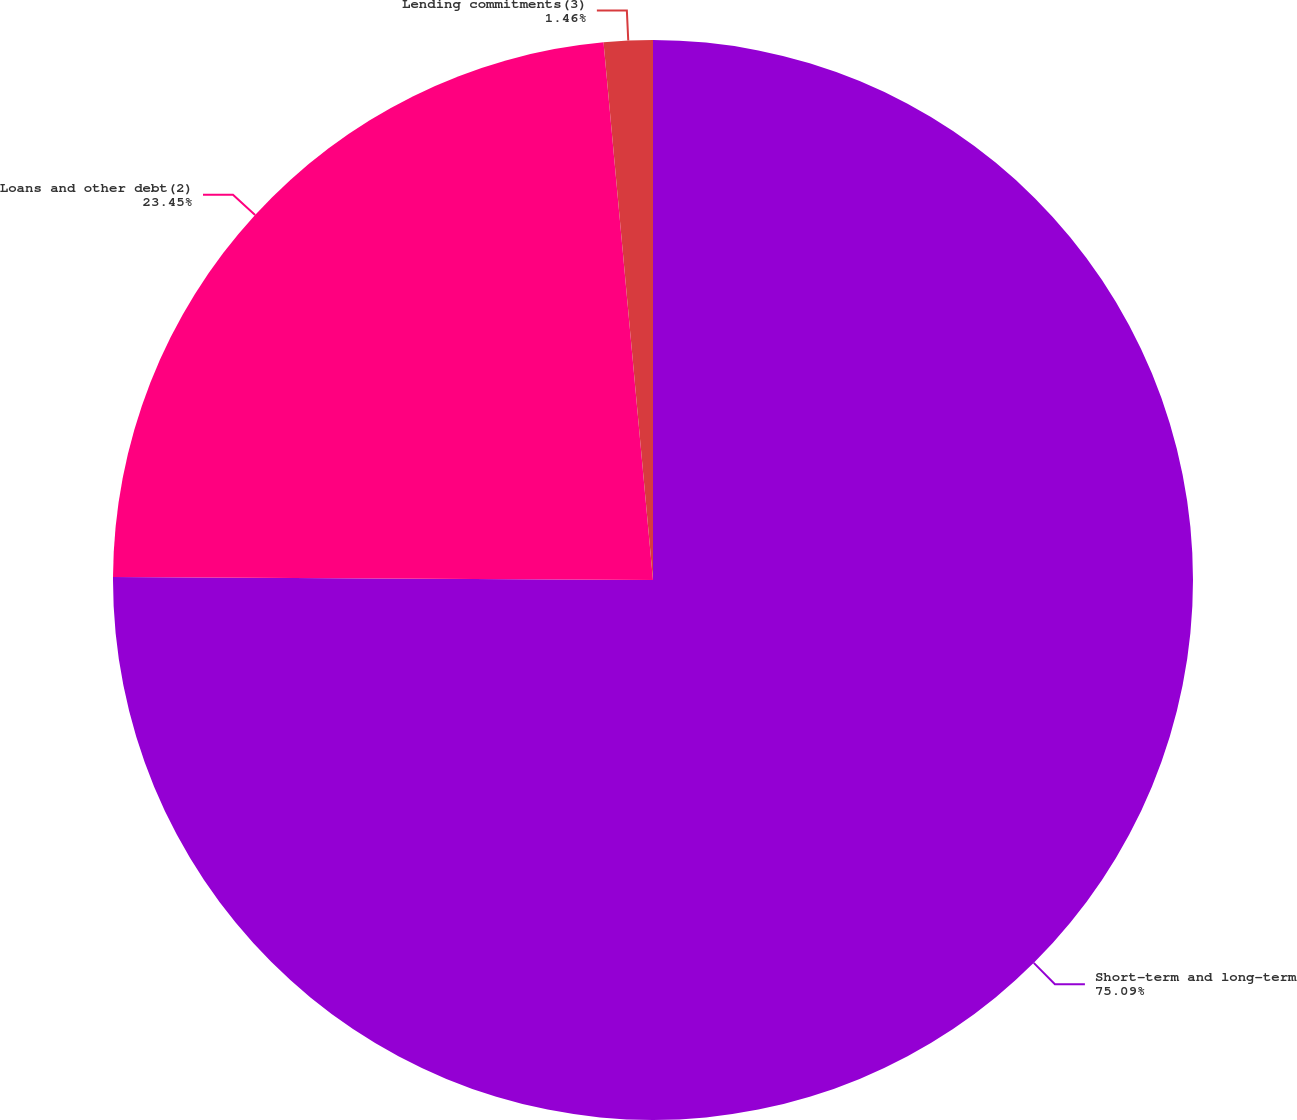Convert chart. <chart><loc_0><loc_0><loc_500><loc_500><pie_chart><fcel>Short-term and long-term<fcel>Loans and other debt(2)<fcel>Lending commitments(3)<nl><fcel>75.09%<fcel>23.45%<fcel>1.46%<nl></chart> 